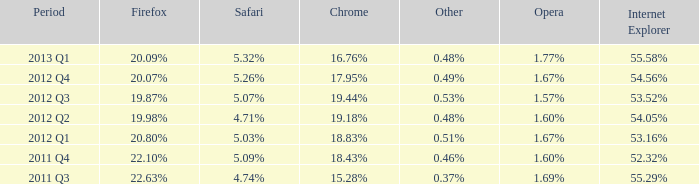What internet explorer has 1.67% as the opera, with 2012 q1 as the period? 53.16%. 